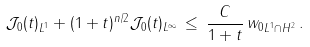<formula> <loc_0><loc_0><loc_500><loc_500>\| \mathcal { J } _ { 0 } ( t ) \| _ { L ^ { 1 } } + ( 1 + t ) ^ { n / 2 } \| \mathcal { J } _ { 0 } ( t ) \| _ { L ^ { \infty } } \, \leq \, \frac { C } { 1 + t } \, \| w _ { 0 } \| _ { L ^ { 1 } \cap H ^ { 2 } } \, .</formula> 